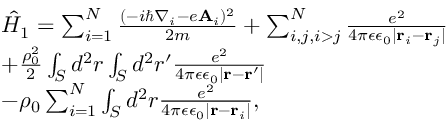<formula> <loc_0><loc_0><loc_500><loc_500>\begin{array} { l } { \hat { H } _ { 1 } = \sum _ { i = 1 } ^ { N } \frac { ( - i \hbar { \nabla } _ { i } - e A _ { i } ) ^ { 2 } } { 2 m } + \sum _ { i , j , i > j } ^ { N } \frac { e ^ { 2 } } { 4 \pi \epsilon \epsilon _ { 0 } | r _ { i } - r _ { j } | } } \\ { + \frac { \rho _ { 0 } ^ { 2 } } { 2 } \int _ { S } d ^ { 2 } r \int _ { S } d ^ { 2 } r ^ { \prime } \frac { e ^ { 2 } } { 4 \pi \epsilon \epsilon _ { 0 } | r - r ^ { \prime } | } } \\ { - \rho _ { 0 } \sum _ { i = 1 } ^ { N } \int _ { S } d ^ { 2 } r \frac { e ^ { 2 } } { 4 \pi \epsilon \epsilon _ { 0 } | r - r _ { i } | } , } \end{array}</formula> 